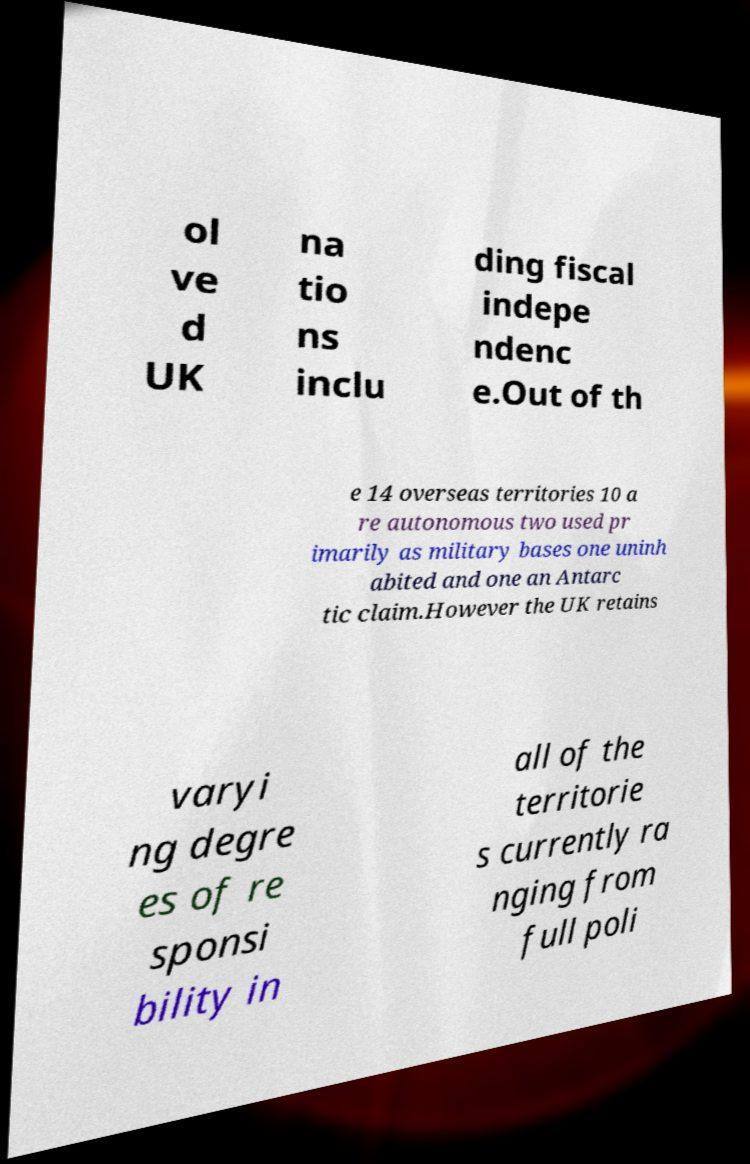For documentation purposes, I need the text within this image transcribed. Could you provide that? ol ve d UK na tio ns inclu ding fiscal indepe ndenc e.Out of th e 14 overseas territories 10 a re autonomous two used pr imarily as military bases one uninh abited and one an Antarc tic claim.However the UK retains varyi ng degre es of re sponsi bility in all of the territorie s currently ra nging from full poli 